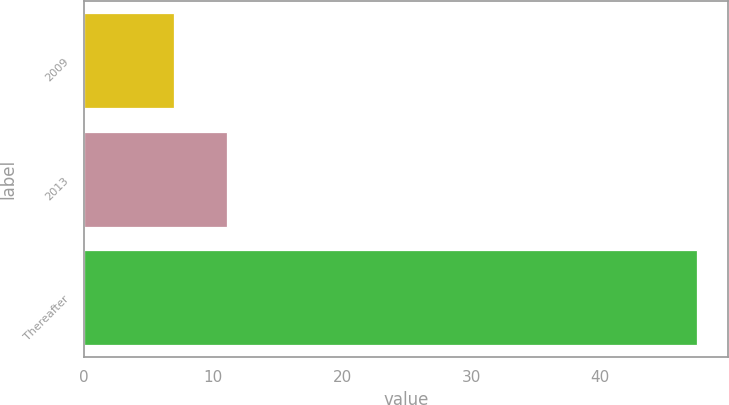<chart> <loc_0><loc_0><loc_500><loc_500><bar_chart><fcel>2009<fcel>2013<fcel>Thereafter<nl><fcel>7<fcel>11.05<fcel>47.5<nl></chart> 